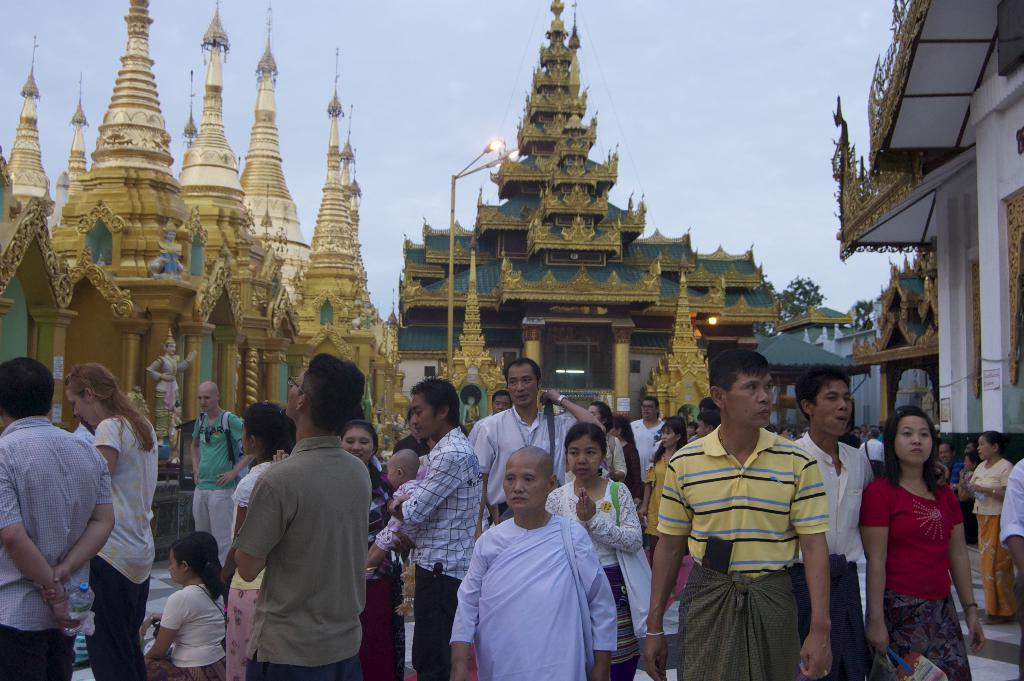What is happening in the image? There are persons standing in the image. Where are the persons located in the image? The persons are at the bottom of the image. What can be seen in the background of the image? There are temples in the background of the image. What is visible at the top of the image? The sky is visible at the top of the image. What is the title of the team in the image? There is no team or title present in the image; it features persons standing near temples. 